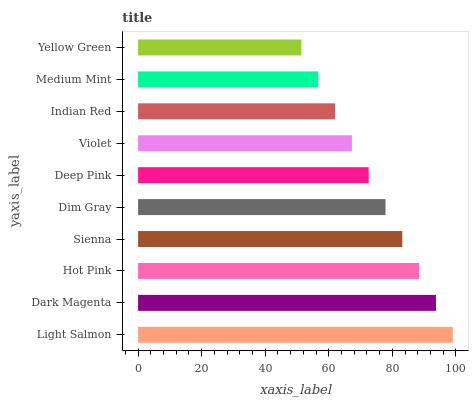Is Yellow Green the minimum?
Answer yes or no. Yes. Is Light Salmon the maximum?
Answer yes or no. Yes. Is Dark Magenta the minimum?
Answer yes or no. No. Is Dark Magenta the maximum?
Answer yes or no. No. Is Light Salmon greater than Dark Magenta?
Answer yes or no. Yes. Is Dark Magenta less than Light Salmon?
Answer yes or no. Yes. Is Dark Magenta greater than Light Salmon?
Answer yes or no. No. Is Light Salmon less than Dark Magenta?
Answer yes or no. No. Is Dim Gray the high median?
Answer yes or no. Yes. Is Deep Pink the low median?
Answer yes or no. Yes. Is Medium Mint the high median?
Answer yes or no. No. Is Dim Gray the low median?
Answer yes or no. No. 